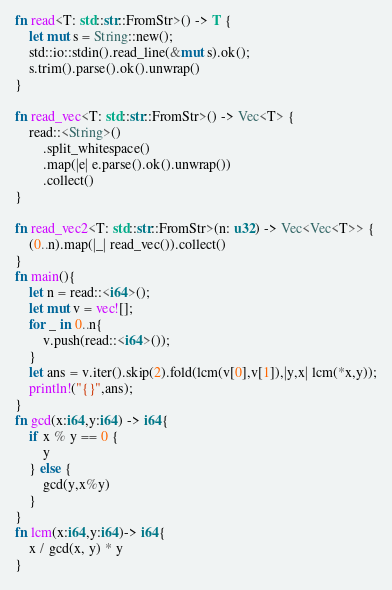Convert code to text. <code><loc_0><loc_0><loc_500><loc_500><_Rust_>fn read<T: std::str::FromStr>() -> T {
    let mut s = String::new();
    std::io::stdin().read_line(&mut s).ok();
    s.trim().parse().ok().unwrap()
}

fn read_vec<T: std::str::FromStr>() -> Vec<T> {
    read::<String>()
        .split_whitespace()
        .map(|e| e.parse().ok().unwrap())
        .collect()
}

fn read_vec2<T: std::str::FromStr>(n: u32) -> Vec<Vec<T>> {
    (0..n).map(|_| read_vec()).collect()
}
fn main(){
    let n = read::<i64>();
    let mut v = vec![];
    for _ in 0..n{
        v.push(read::<i64>());
    } 
    let ans = v.iter().skip(2).fold(lcm(v[0],v[1]),|y,x| lcm(*x,y));
    println!("{}",ans);
}
fn gcd(x:i64,y:i64) -> i64{
    if x % y == 0 {
        y
    } else {
        gcd(y,x%y)
    }
}
fn lcm(x:i64,y:i64)-> i64{
    x / gcd(x, y) * y
}</code> 